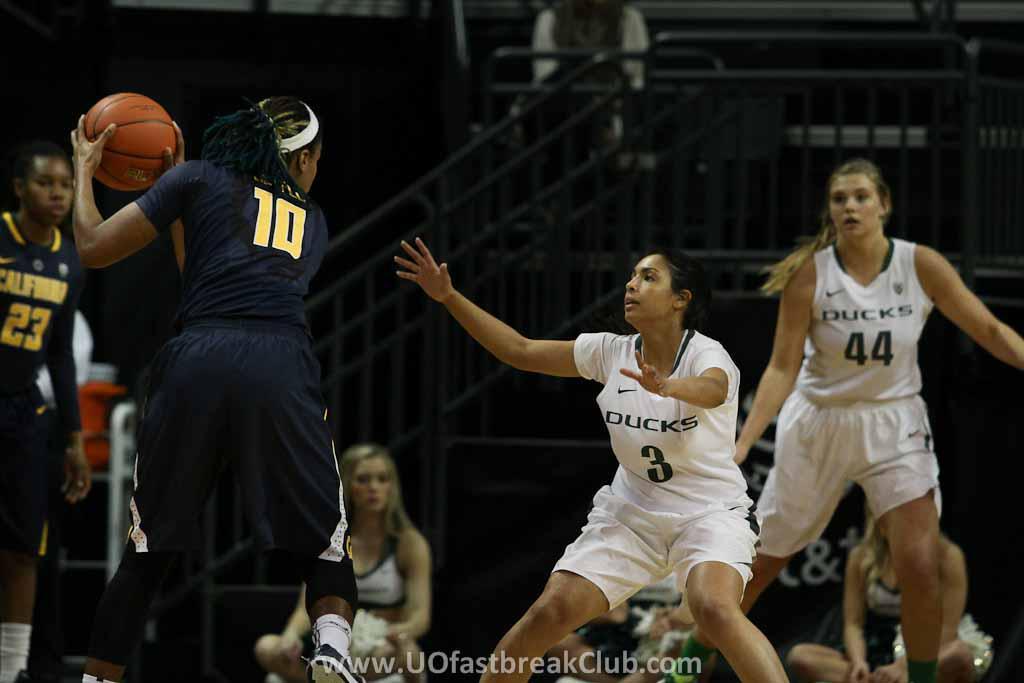Can you describe this image briefly? In the center of the image there are people playing basketball. At the bottom of the image there is some text. In the background of the image there are staircase railings. 